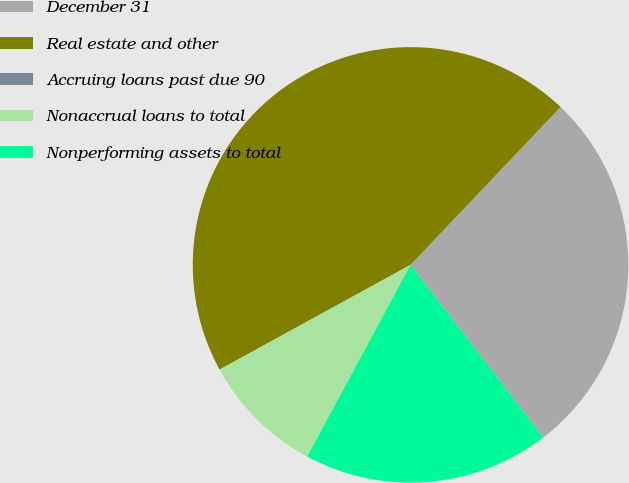Convert chart. <chart><loc_0><loc_0><loc_500><loc_500><pie_chart><fcel>December 31<fcel>Real estate and other<fcel>Accruing loans past due 90<fcel>Nonaccrual loans to total<fcel>Nonperforming assets to total<nl><fcel>27.46%<fcel>45.08%<fcel>0.0%<fcel>9.15%<fcel>18.31%<nl></chart> 